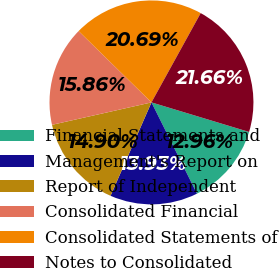<chart> <loc_0><loc_0><loc_500><loc_500><pie_chart><fcel>Financial Statements and<fcel>Management's Report on<fcel>Report of Independent<fcel>Consolidated Financial<fcel>Consolidated Statements of<fcel>Notes to Consolidated<nl><fcel>12.96%<fcel>13.93%<fcel>14.9%<fcel>15.86%<fcel>20.69%<fcel>21.66%<nl></chart> 